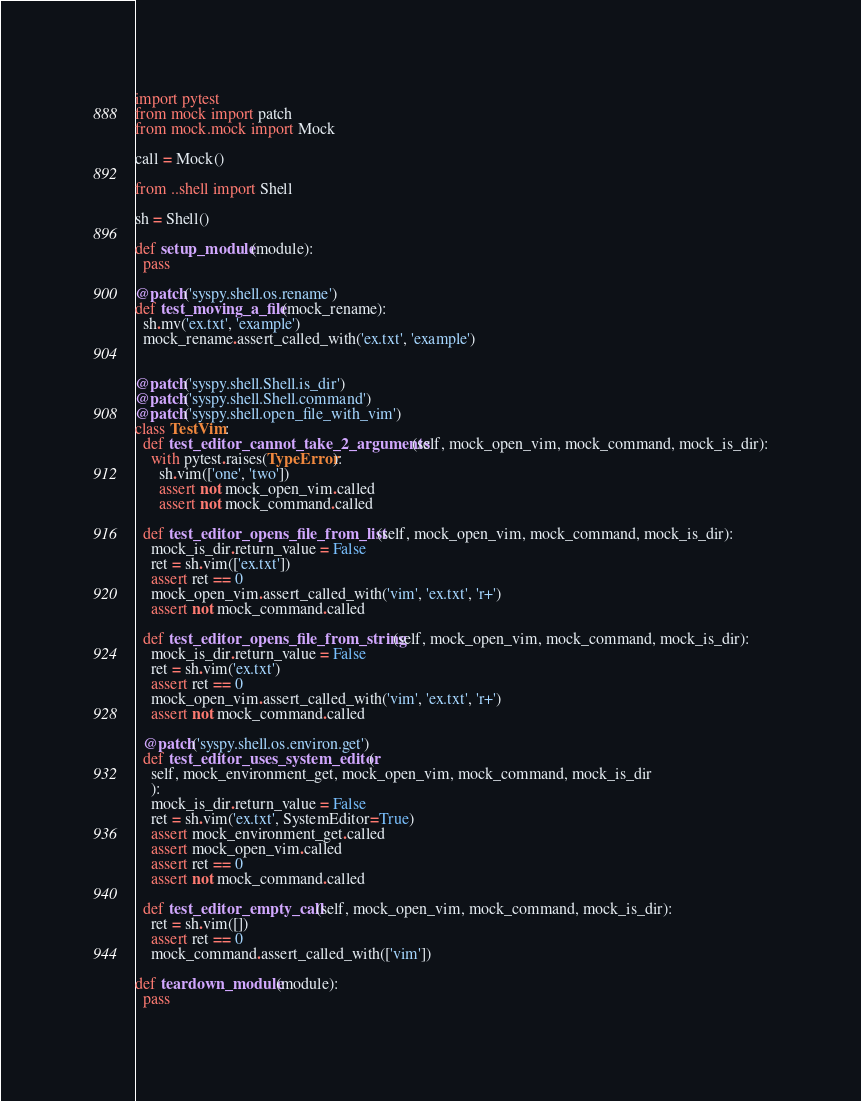<code> <loc_0><loc_0><loc_500><loc_500><_Python_>import pytest
from mock import patch
from mock.mock import Mock

call = Mock()

from ..shell import Shell

sh = Shell()

def setup_module(module):
  pass

@patch('syspy.shell.os.rename')
def test_moving_a_file(mock_rename):
  sh.mv('ex.txt', 'example')
  mock_rename.assert_called_with('ex.txt', 'example')


@patch('syspy.shell.Shell.is_dir')
@patch('syspy.shell.Shell.command')
@patch('syspy.shell.open_file_with_vim')
class TestVim:
  def test_editor_cannot_take_2_arguments(self, mock_open_vim, mock_command, mock_is_dir):
    with pytest.raises(TypeError):
      sh.vim(['one', 'two'])
      assert not mock_open_vim.called
      assert not mock_command.called

  def test_editor_opens_file_from_list(self, mock_open_vim, mock_command, mock_is_dir):
    mock_is_dir.return_value = False
    ret = sh.vim(['ex.txt'])
    assert ret == 0
    mock_open_vim.assert_called_with('vim', 'ex.txt', 'r+')
    assert not mock_command.called

  def test_editor_opens_file_from_string(self, mock_open_vim, mock_command, mock_is_dir):
    mock_is_dir.return_value = False
    ret = sh.vim('ex.txt')
    assert ret == 0
    mock_open_vim.assert_called_with('vim', 'ex.txt', 'r+')
    assert not mock_command.called

  @patch('syspy.shell.os.environ.get')
  def test_editor_uses_system_editor(
    self, mock_environment_get, mock_open_vim, mock_command, mock_is_dir
    ):
    mock_is_dir.return_value = False
    ret = sh.vim('ex.txt', SystemEditor=True)
    assert mock_environment_get.called
    assert mock_open_vim.called
    assert ret == 0
    assert not mock_command.called

  def test_editor_empty_call(self, mock_open_vim, mock_command, mock_is_dir):
    ret = sh.vim([])
    assert ret == 0
    mock_command.assert_called_with(['vim'])

def teardown_module(module):
  pass
</code> 